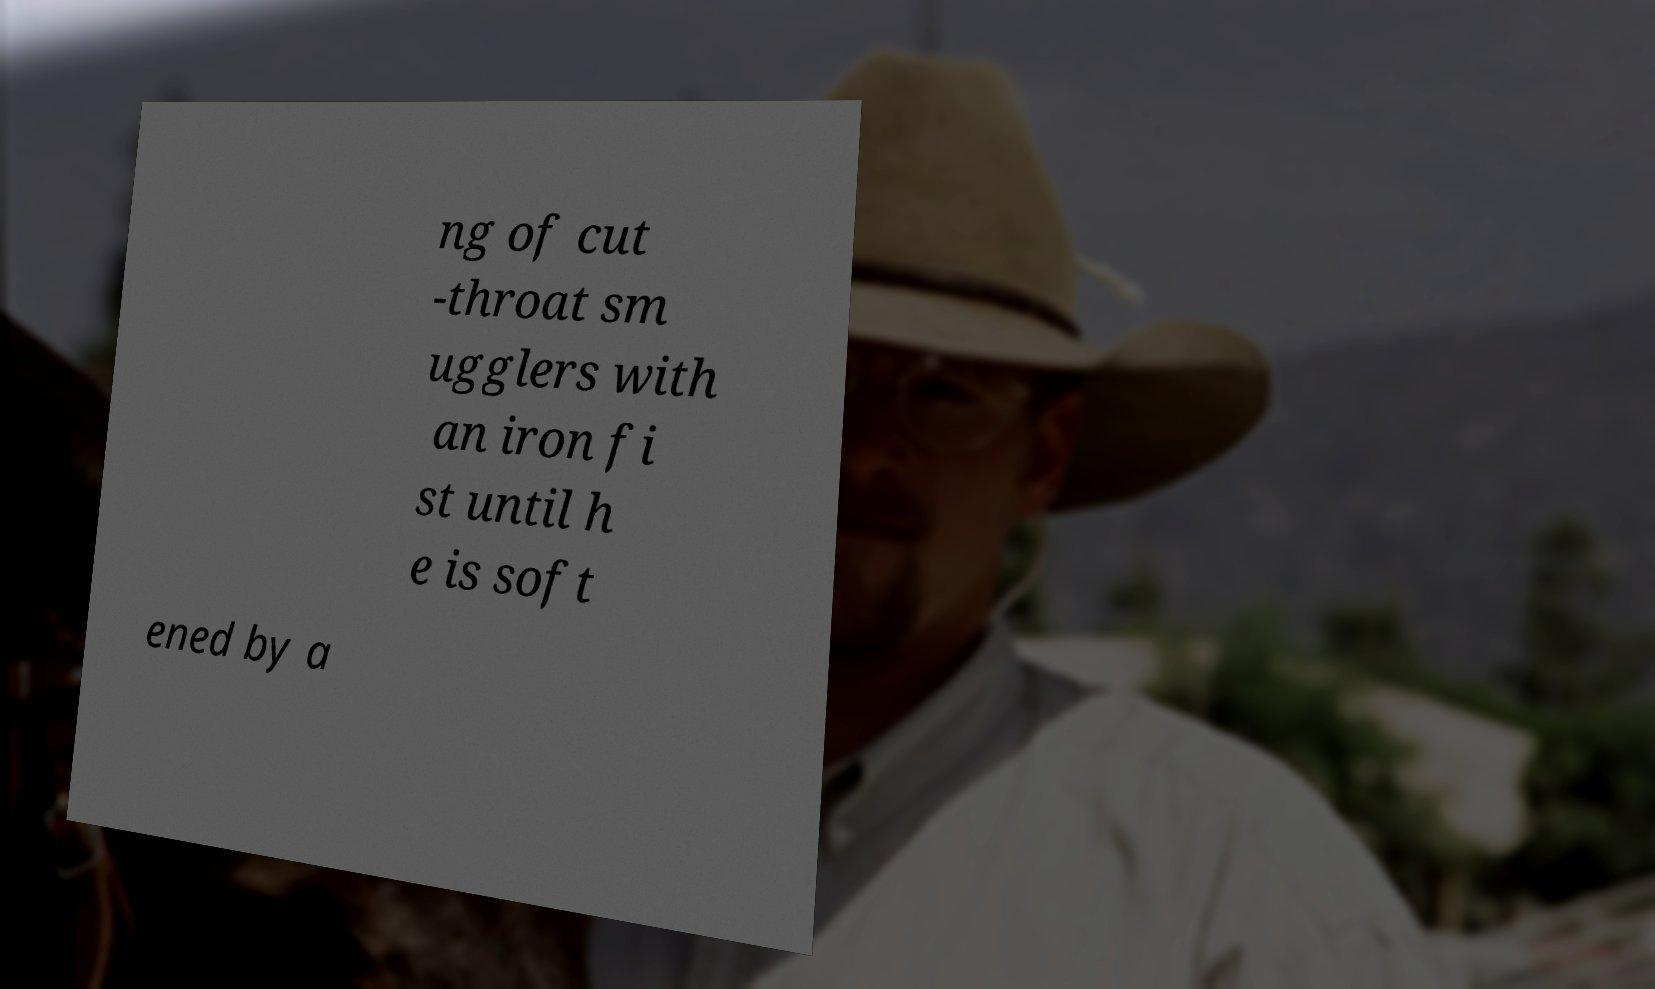Can you read and provide the text displayed in the image?This photo seems to have some interesting text. Can you extract and type it out for me? ng of cut -throat sm ugglers with an iron fi st until h e is soft ened by a 